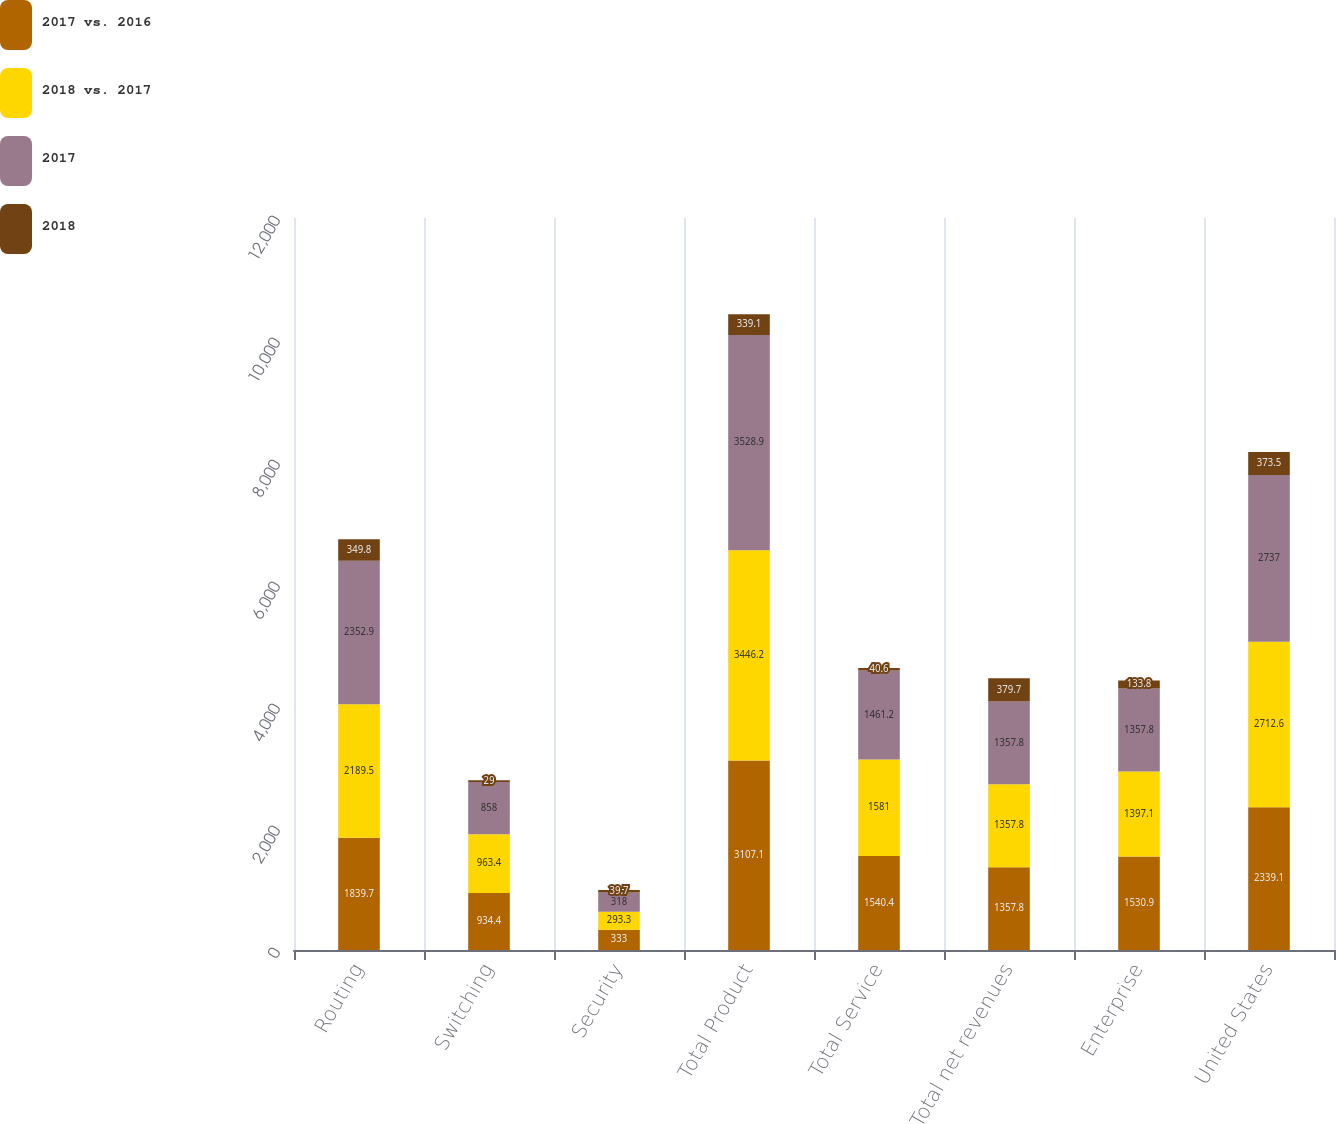Convert chart to OTSL. <chart><loc_0><loc_0><loc_500><loc_500><stacked_bar_chart><ecel><fcel>Routing<fcel>Switching<fcel>Security<fcel>Total Product<fcel>Total Service<fcel>Total net revenues<fcel>Enterprise<fcel>United States<nl><fcel>2017 vs. 2016<fcel>1839.7<fcel>934.4<fcel>333<fcel>3107.1<fcel>1540.4<fcel>1357.8<fcel>1530.9<fcel>2339.1<nl><fcel>2018 vs. 2017<fcel>2189.5<fcel>963.4<fcel>293.3<fcel>3446.2<fcel>1581<fcel>1357.8<fcel>1397.1<fcel>2712.6<nl><fcel>2017<fcel>2352.9<fcel>858<fcel>318<fcel>3528.9<fcel>1461.2<fcel>1357.8<fcel>1357.8<fcel>2737<nl><fcel>2018<fcel>349.8<fcel>29<fcel>39.7<fcel>339.1<fcel>40.6<fcel>379.7<fcel>133.8<fcel>373.5<nl></chart> 